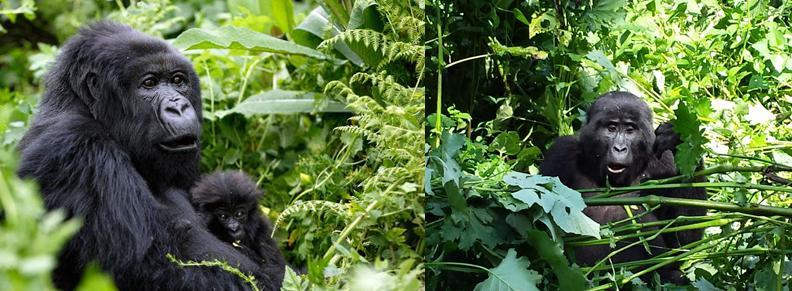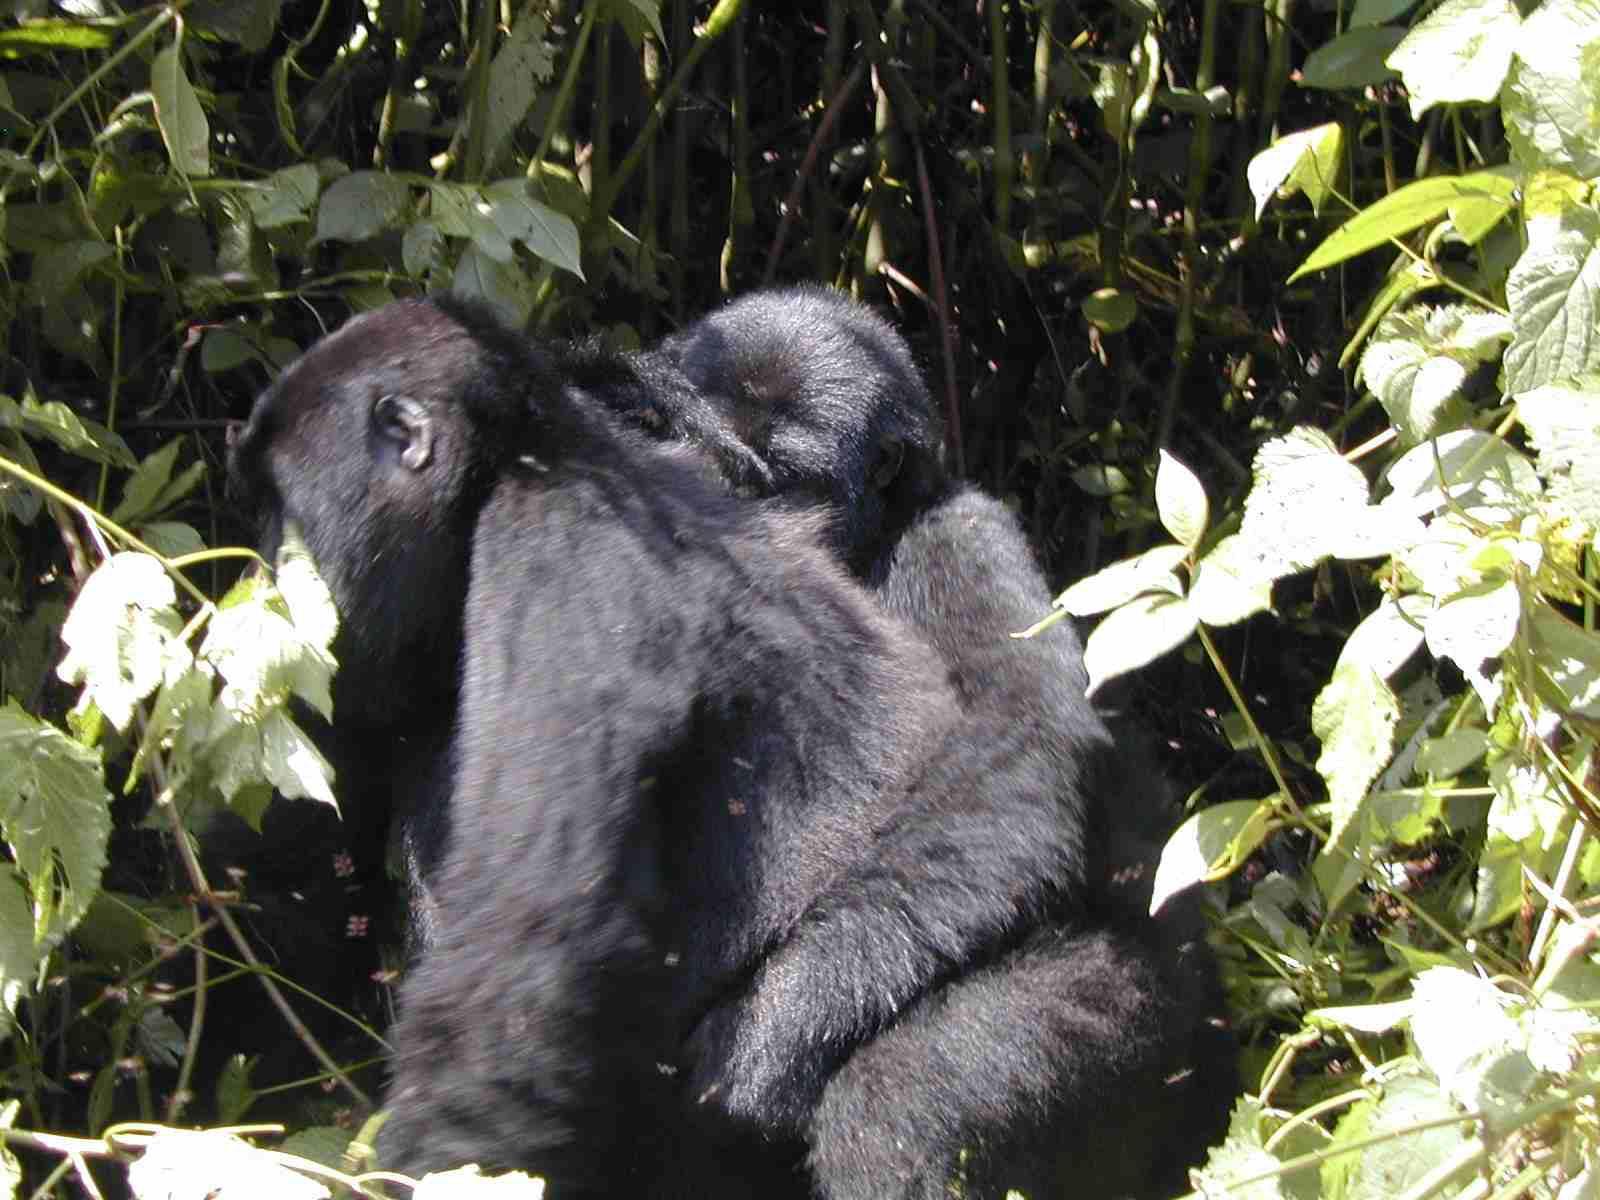The first image is the image on the left, the second image is the image on the right. Evaluate the accuracy of this statement regarding the images: "The right image contains no more than two gorillas.". Is it true? Answer yes or no. Yes. 